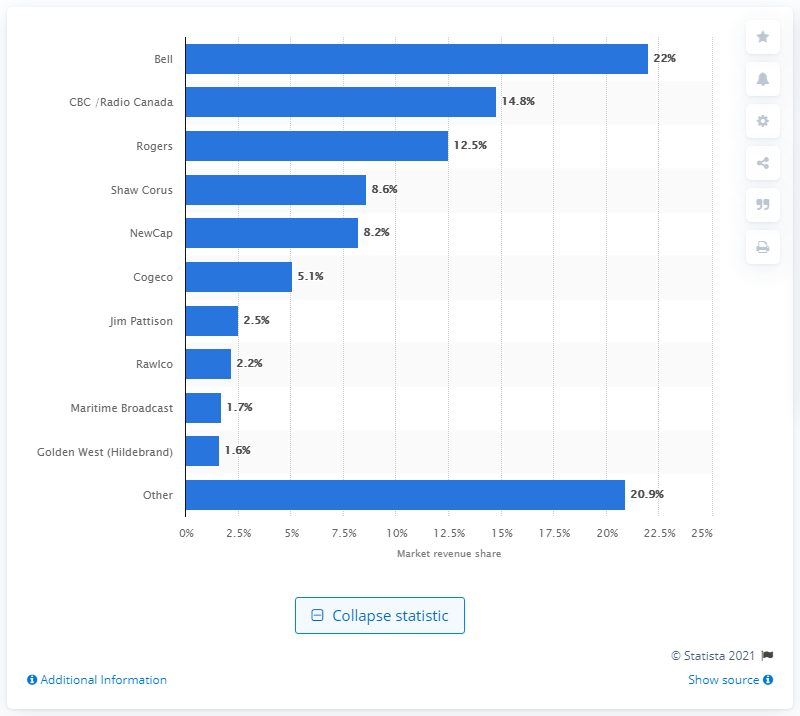Point out several critical features in this image. In 2015, Rogers accounted for 14.8% of the radio market revenues. 